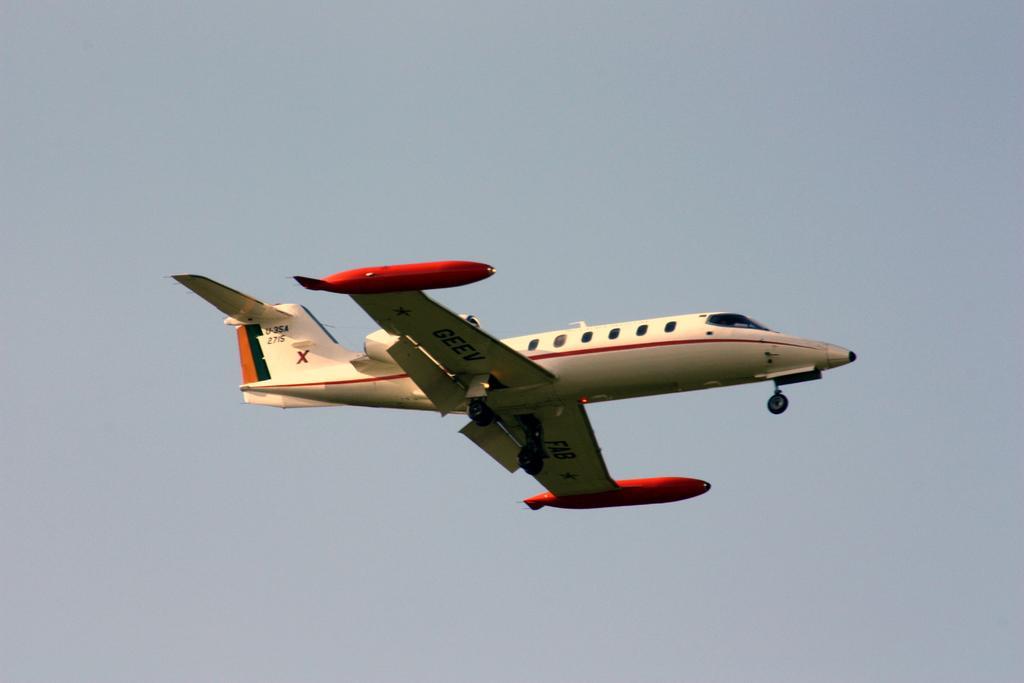How would you summarize this image in a sentence or two? This image is taken outdoors. In the background there is a sky. In the middle of the image an airplane is flying in the sky. 